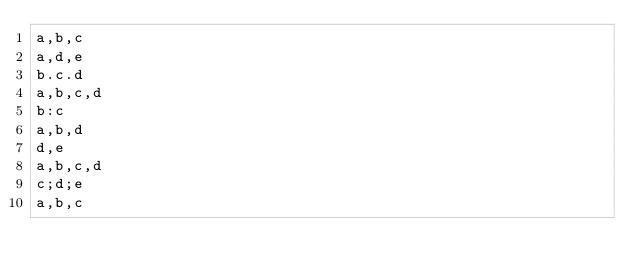Convert code to text. <code><loc_0><loc_0><loc_500><loc_500><_SQL_>a,b,c
a,d,e
b.c.d
a,b,c,d
b:c
a,b,d
d,e
a,b,c,d
c;d;e
a,b,c
</code> 